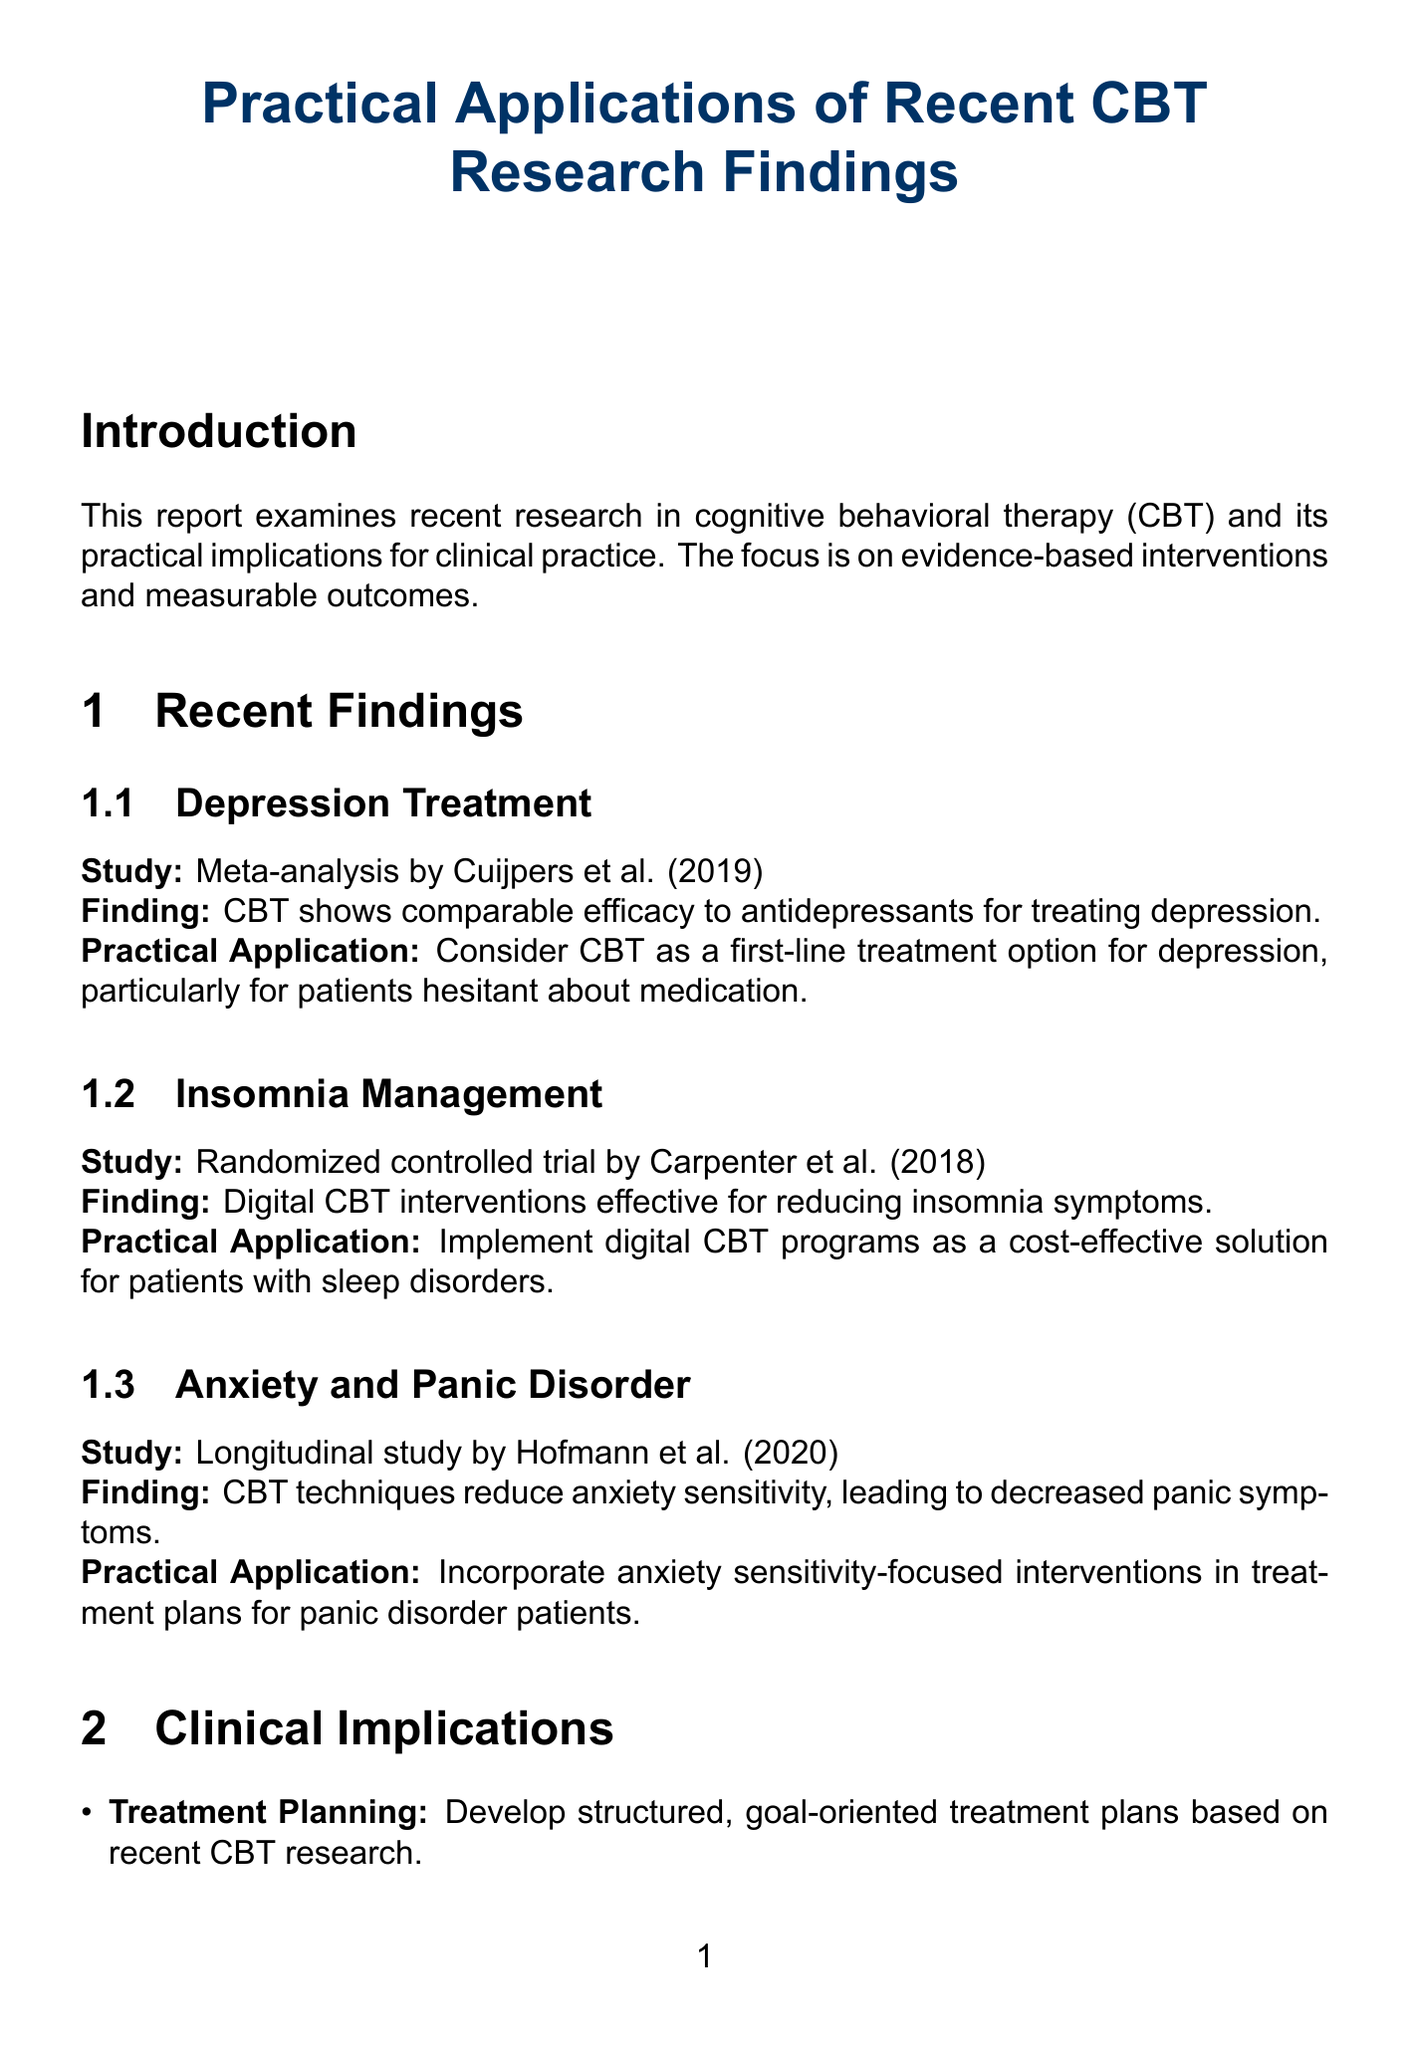what is the title of the report? The title of the report is clearly stated at the top of the document.
Answer: Practical Applications of Recent CBT Research Findings who conducted the meta-analysis on depression treatment? The name of the author of the meta-analysis can be found in the recent findings section.
Answer: Cuijpers et al what year was the longitudinal study on anxiety sensitivity published? The publication year of the longitudinal study is mentioned in the recent findings section.
Answer: 2020 what is one digital CBT program recommended for insomnia? A specific digital CBT program is listed under practical applications in the recent findings section.
Answer: Cost-effective solution which patient underwent virtual reality exposure therapy? The case study section details specific patients and their interventions.
Answer: Sarah what is a recommended action for treatment planning? The clinical implications section outlines recommended actions for various areas, including treatment planning.
Answer: Use standardized assessment tools how long was the mindfulness-based CBT program for chronic pain and depression? The duration of the program is stated in one of the case studies.
Answer: 12-week program what type of intervention was used for Sarah? The type of intervention for the patient named Sarah is specified in the case studies section.
Answer: Virtual reality exposure therapy which technique is suggested for integrating CBT into practice? Suggestions for integrating CBT techniques can be found in the clinical implications section.
Answer: Exposure therapy for anxiety disorders 